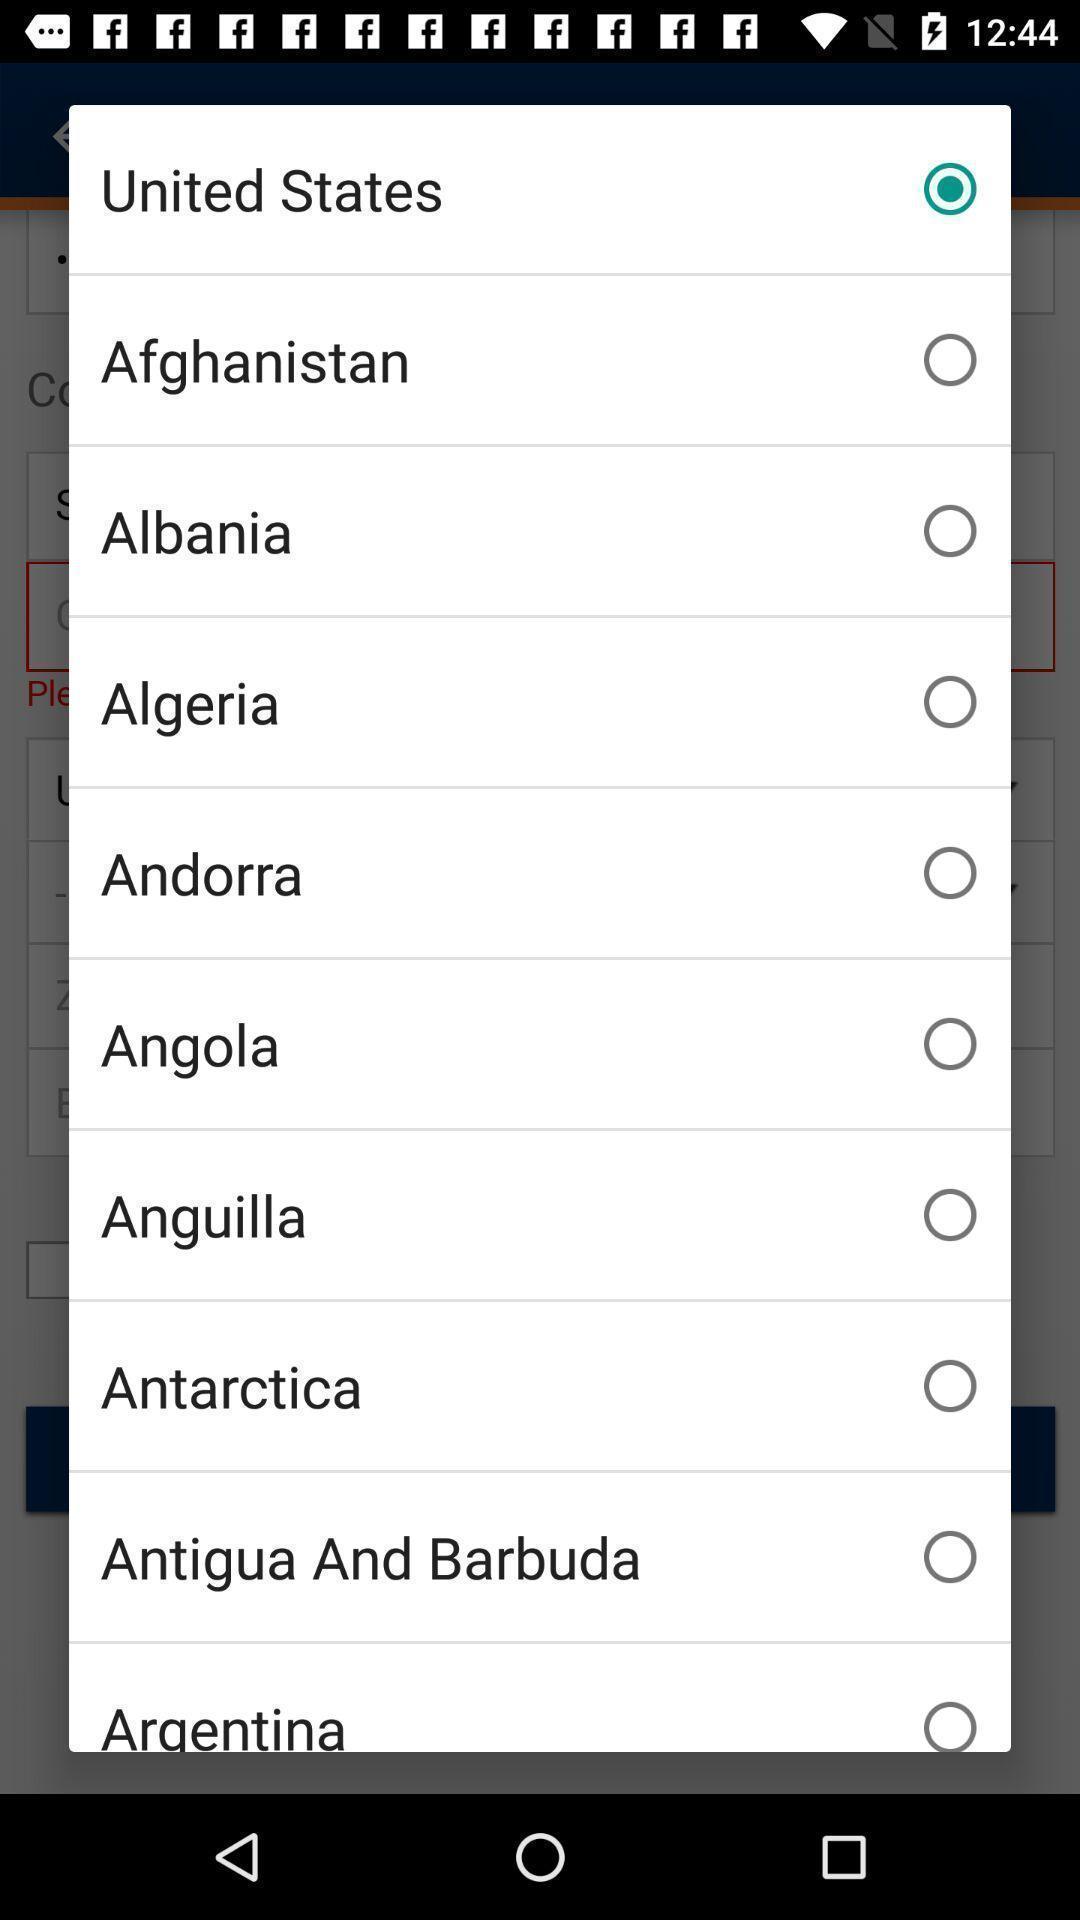Describe the key features of this screenshot. Pop-up showing to select country. 